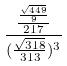Convert formula to latex. <formula><loc_0><loc_0><loc_500><loc_500>\frac { \frac { \frac { \sqrt { 4 4 9 } } { 9 } } { 2 1 7 } } { ( \frac { \sqrt { 3 1 8 } } { 3 1 3 } ) ^ { 3 } }</formula> 